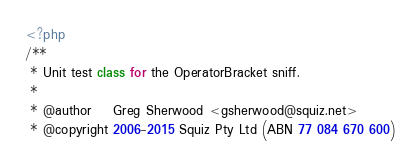<code> <loc_0><loc_0><loc_500><loc_500><_PHP_><?php
/**
 * Unit test class for the OperatorBracket sniff.
 *
 * @author    Greg Sherwood <gsherwood@squiz.net>
 * @copyright 2006-2015 Squiz Pty Ltd (ABN 77 084 670 600)</code> 